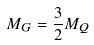Convert formula to latex. <formula><loc_0><loc_0><loc_500><loc_500>M _ { G } = \frac { 3 } { 2 } M _ { Q }</formula> 